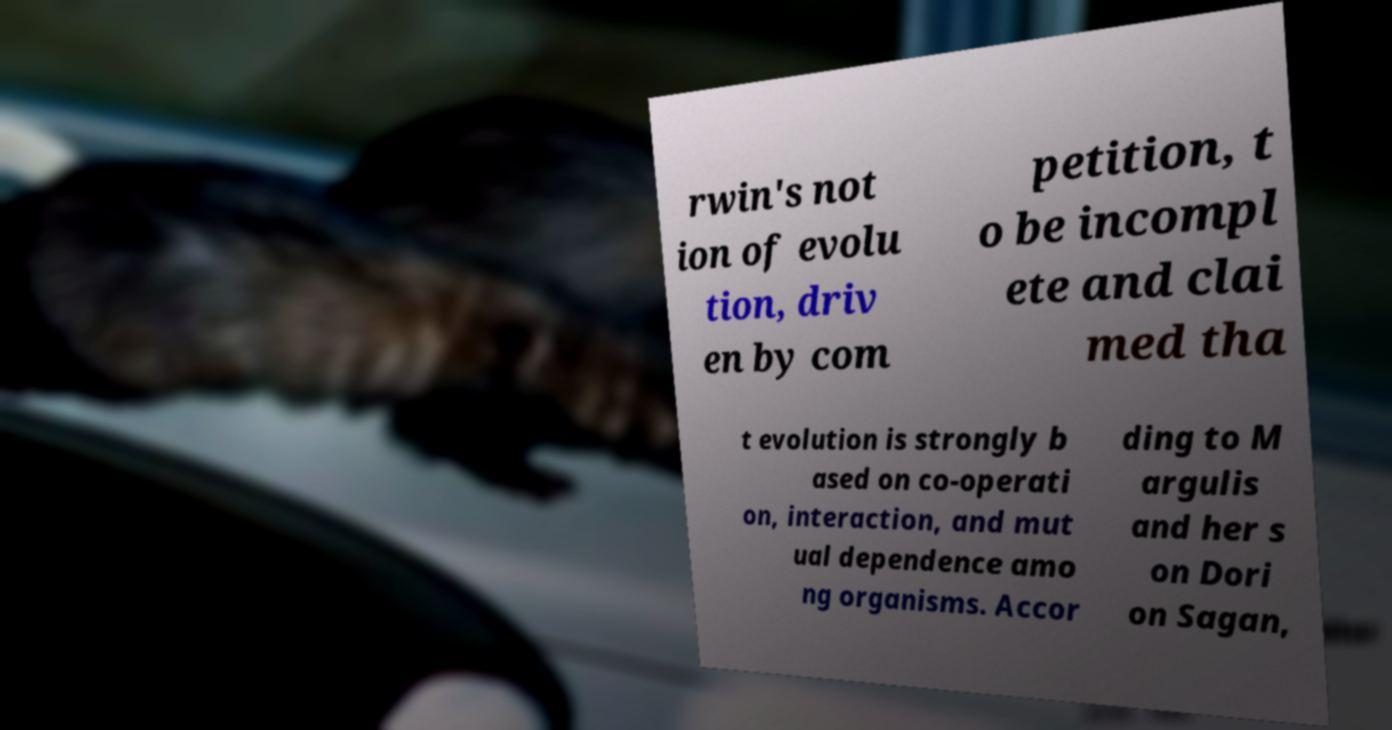There's text embedded in this image that I need extracted. Can you transcribe it verbatim? rwin's not ion of evolu tion, driv en by com petition, t o be incompl ete and clai med tha t evolution is strongly b ased on co-operati on, interaction, and mut ual dependence amo ng organisms. Accor ding to M argulis and her s on Dori on Sagan, 